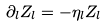<formula> <loc_0><loc_0><loc_500><loc_500>\partial _ { l } Z _ { l } = - \eta _ { l } Z _ { l }</formula> 